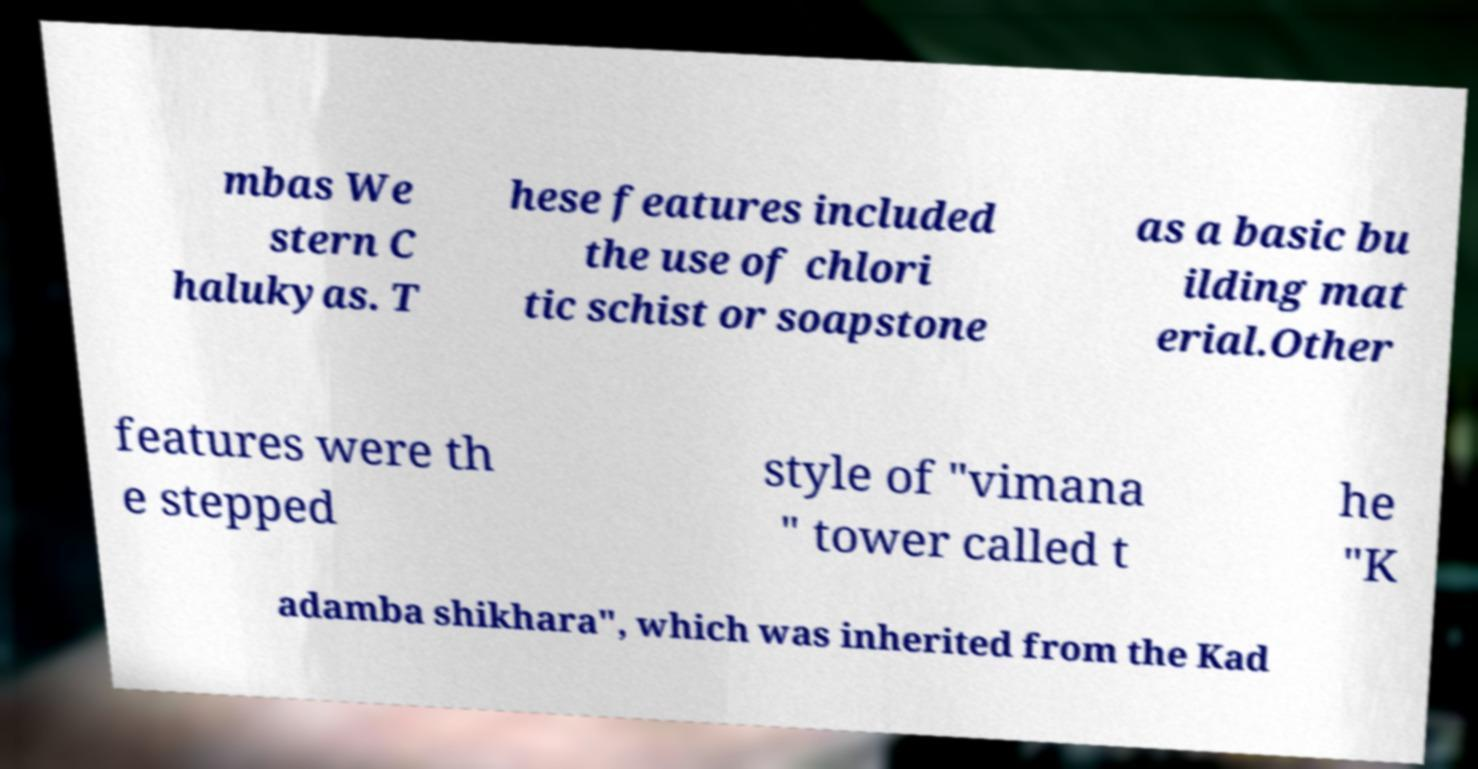Please read and relay the text visible in this image. What does it say? mbas We stern C halukyas. T hese features included the use of chlori tic schist or soapstone as a basic bu ilding mat erial.Other features were th e stepped style of "vimana " tower called t he "K adamba shikhara", which was inherited from the Kad 